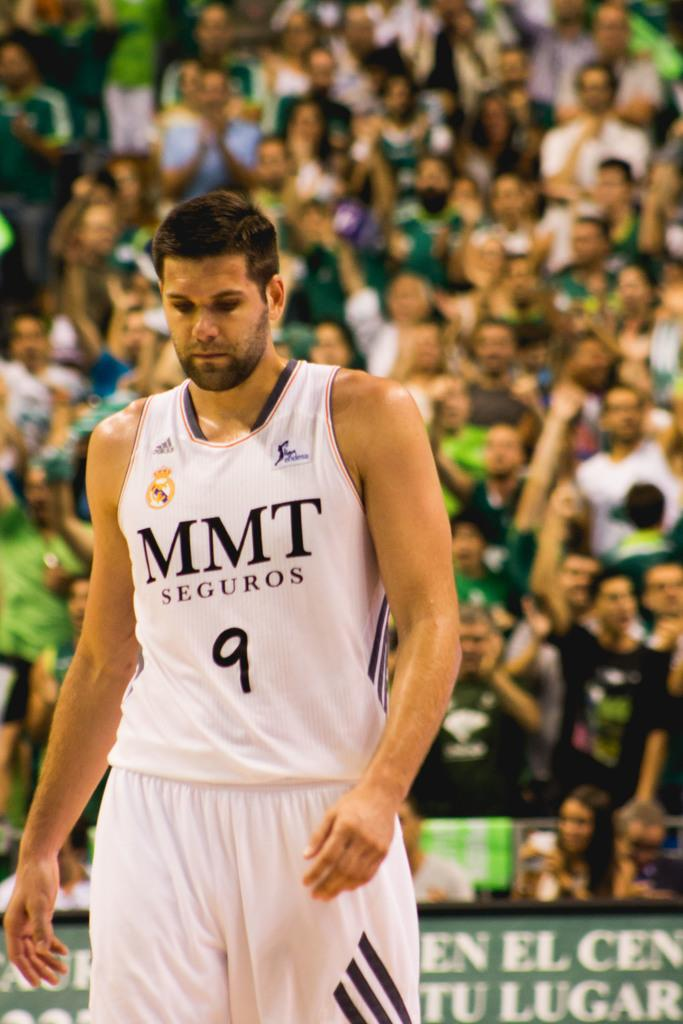<image>
Offer a succinct explanation of the picture presented. Athletic play with the jersey mmt seguros wrote on the front 